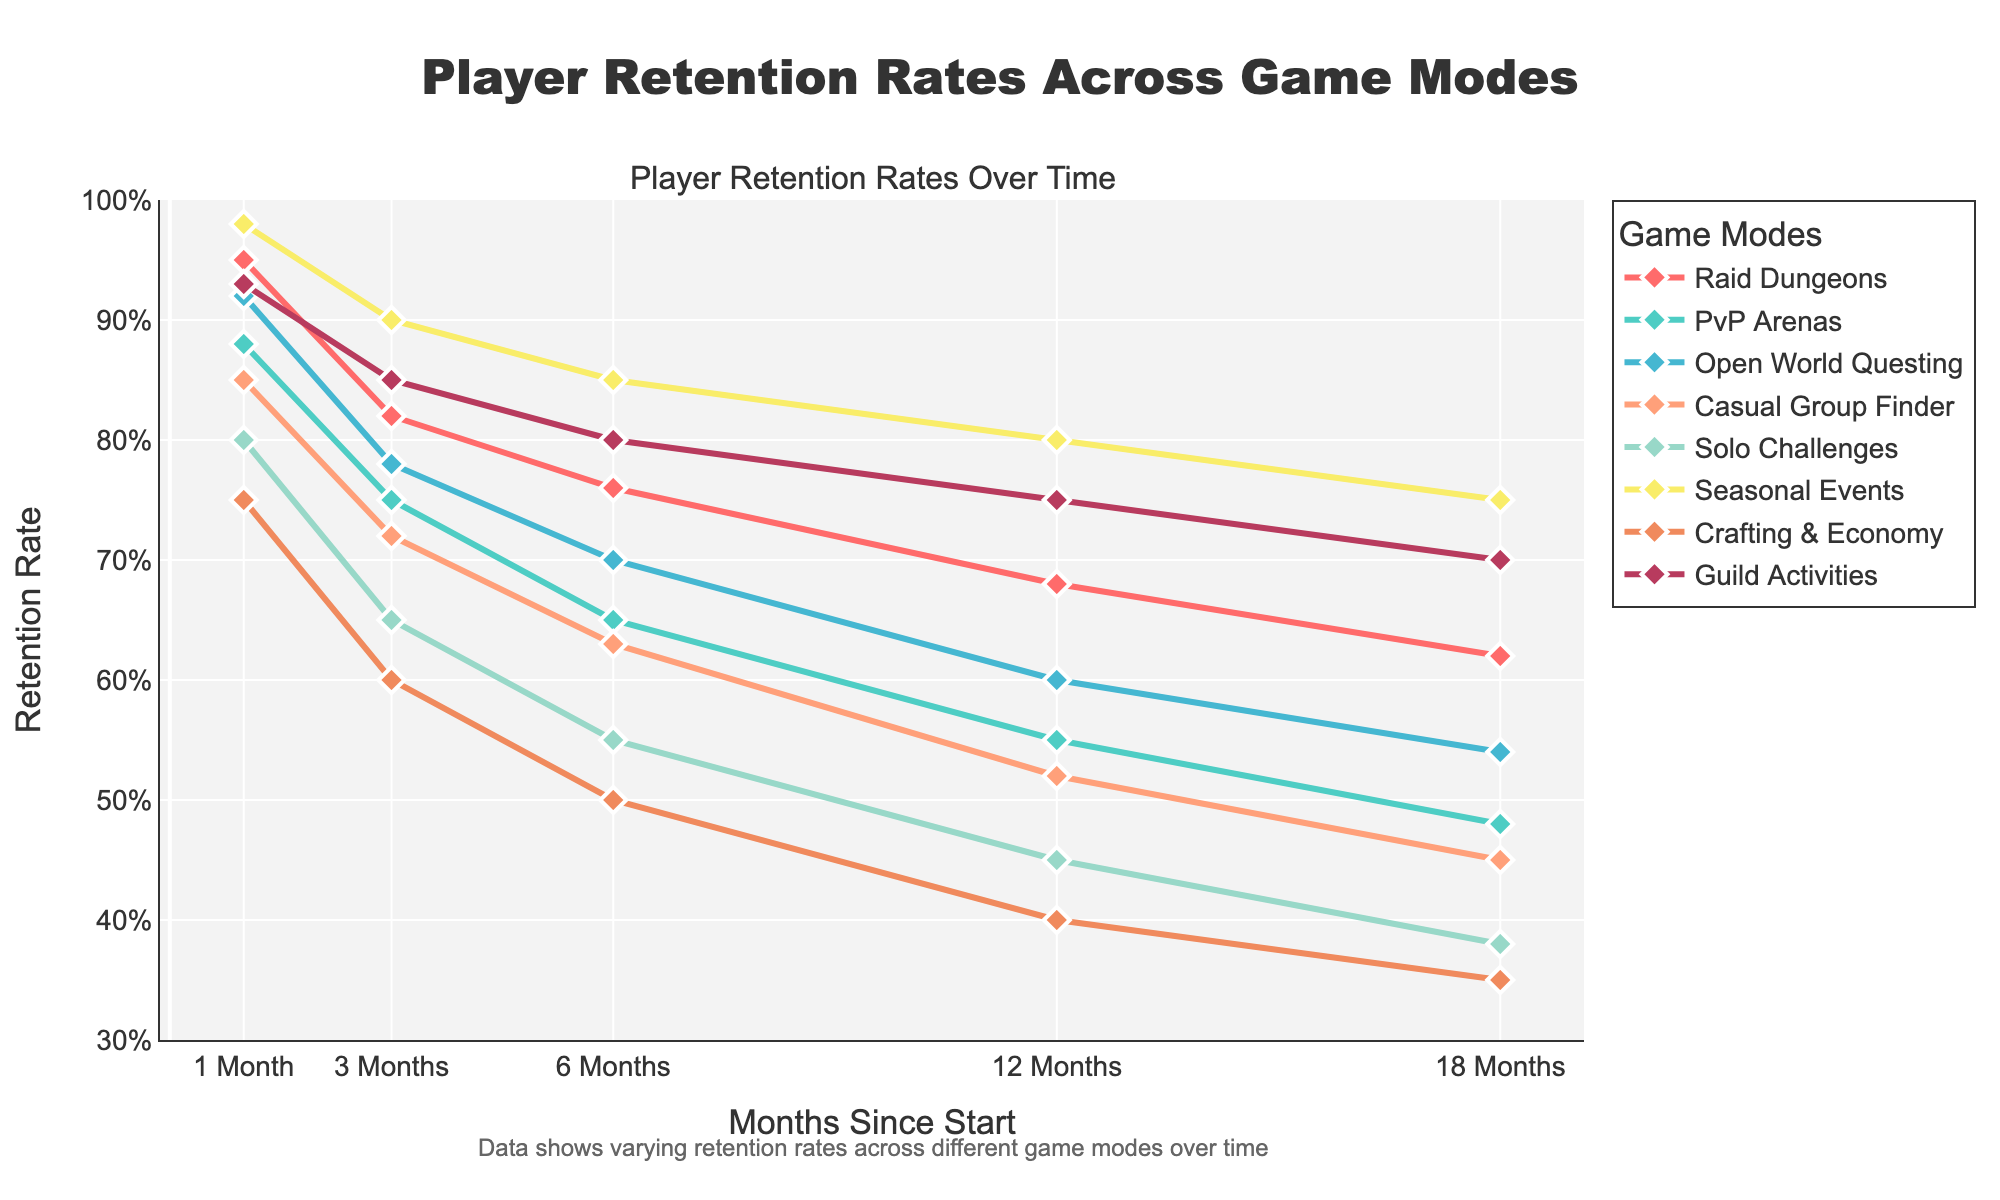Which game mode has the highest retention rate at 1 month? The point for 1 month on the x-axis shows that the "Seasonal Events" line starts at 98%, which is higher than all the other lines at 1 month.
Answer: Seasonal Events How much does the retention rate of Solo Challenges decline from month 1 to month 18? At month 1, the retention rate for Solo Challenges is 80%, and at month 18 it is 38%. The difference between these two values is 80% - 38% = 42%.
Answer: 42% Compare the slopes of the Raid Dungeons and PvP Arenas lines between month 6 and month 12. Which one decreases more steeply? From month 6 to month 12, Raid Dungeons decrease from 76% to 68% (a decrease of 8%), while PvP Arenas decrease from 65% to 55% (a decrease of 10%). Since 10% is greater than 8%, PvP Arenas decrease more steeply.
Answer: PvP Arenas What is the average retention rate for Guild Activities at months 1, 3, and 6? Retention rates for Guild Activities at months 1, 3, and 6 are 93%, 85%, and 80%, respectively. Average = (93% + 85% + 80%) / 3 = 86%.
Answer: 86% Which game mode has the lowest retention rate at month 18? At month 18 on the x-axis, "Crafting & Economy" ends at 35%, which is the lowest among all game modes.
Answer: Crafting & Economy Identify the game mode with the least change in retention rate from month 12 to month 18. Between month 12 and month 18, Seasonal Events change from 80% to 75% (5%), Raid Dungeons change from 68% to 62% (6%), and all others change more. Thus, Seasonal Events have the least change (5%).
Answer: Seasonal Events Considering only Raid Dungeons and Open World Questing, find the difference in retention rates at month 6 and 12 for each mode and determine which mode exhibits a smaller difference. For Raid Dungeons: at month 6 is 76%, month 12 is 68% (76% - 68% = 8%). For Open World Questing: at month 6 is 70%, month 12 is 60% (70% - 60% = 10%). Thus, Raid Dungeons exhibit a smaller difference (8% vs 10%).
Answer: Raid Dungeons What is the visual difference between the retention rates of Casual Group Finder and PvP Arenas at month 3? Casual Group Finder's line at month 3 is at 72%, and PvP Arenas is at 75%. The visual difference between these two points on the y-axis is 75% - 72% = 3%.
Answer: 3% 